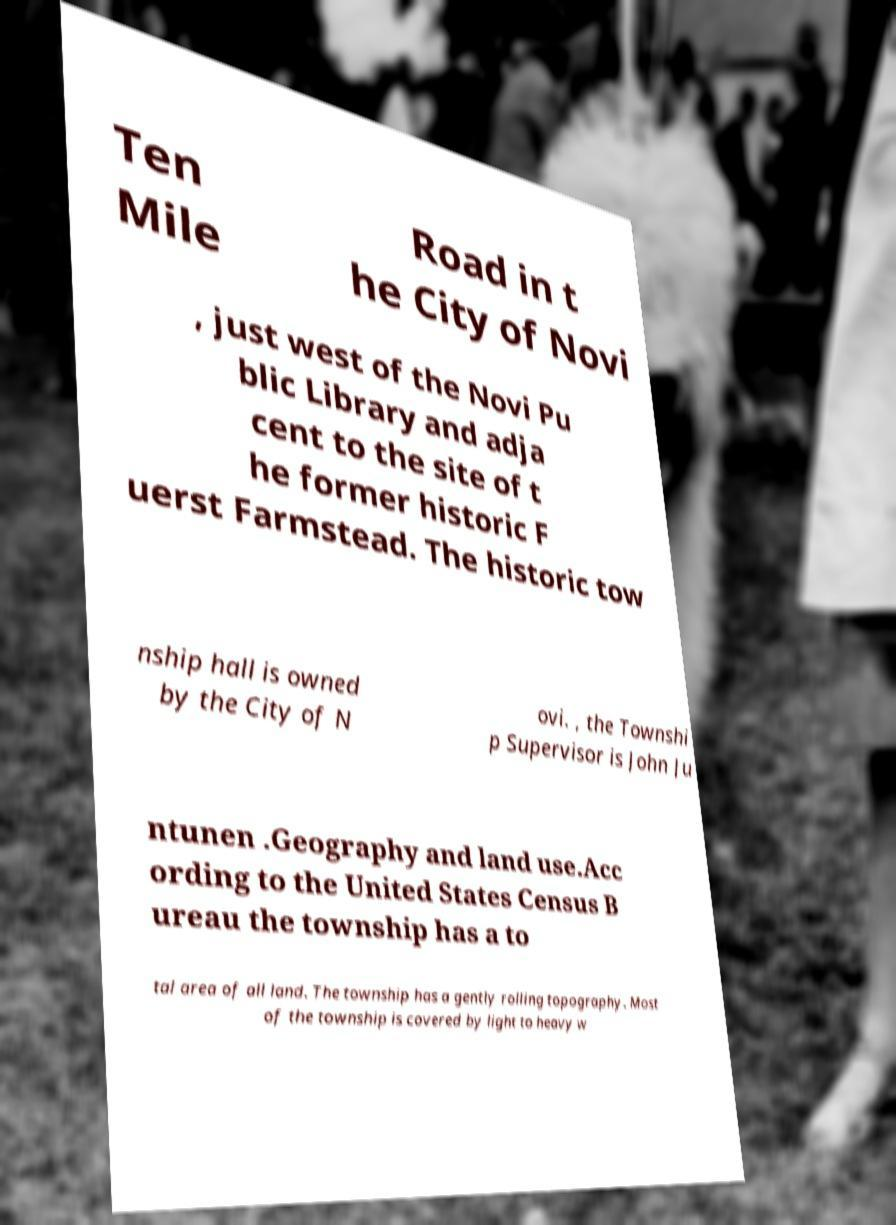Can you accurately transcribe the text from the provided image for me? Ten Mile Road in t he City of Novi , just west of the Novi Pu blic Library and adja cent to the site of t he former historic F uerst Farmstead. The historic tow nship hall is owned by the City of N ovi. , the Townshi p Supervisor is John Ju ntunen .Geography and land use.Acc ording to the United States Census B ureau the township has a to tal area of all land. The township has a gently rolling topography. Most of the township is covered by light to heavy w 